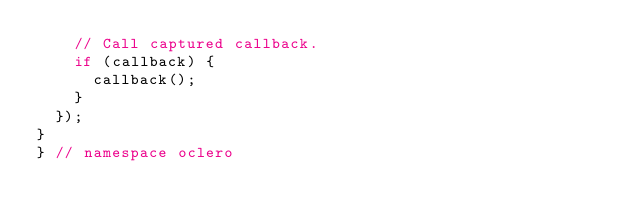Convert code to text. <code><loc_0><loc_0><loc_500><loc_500><_C++_>    // Call captured callback.
    if (callback) {
      callback();
    }
  });
}
} // namespace oclero
</code> 